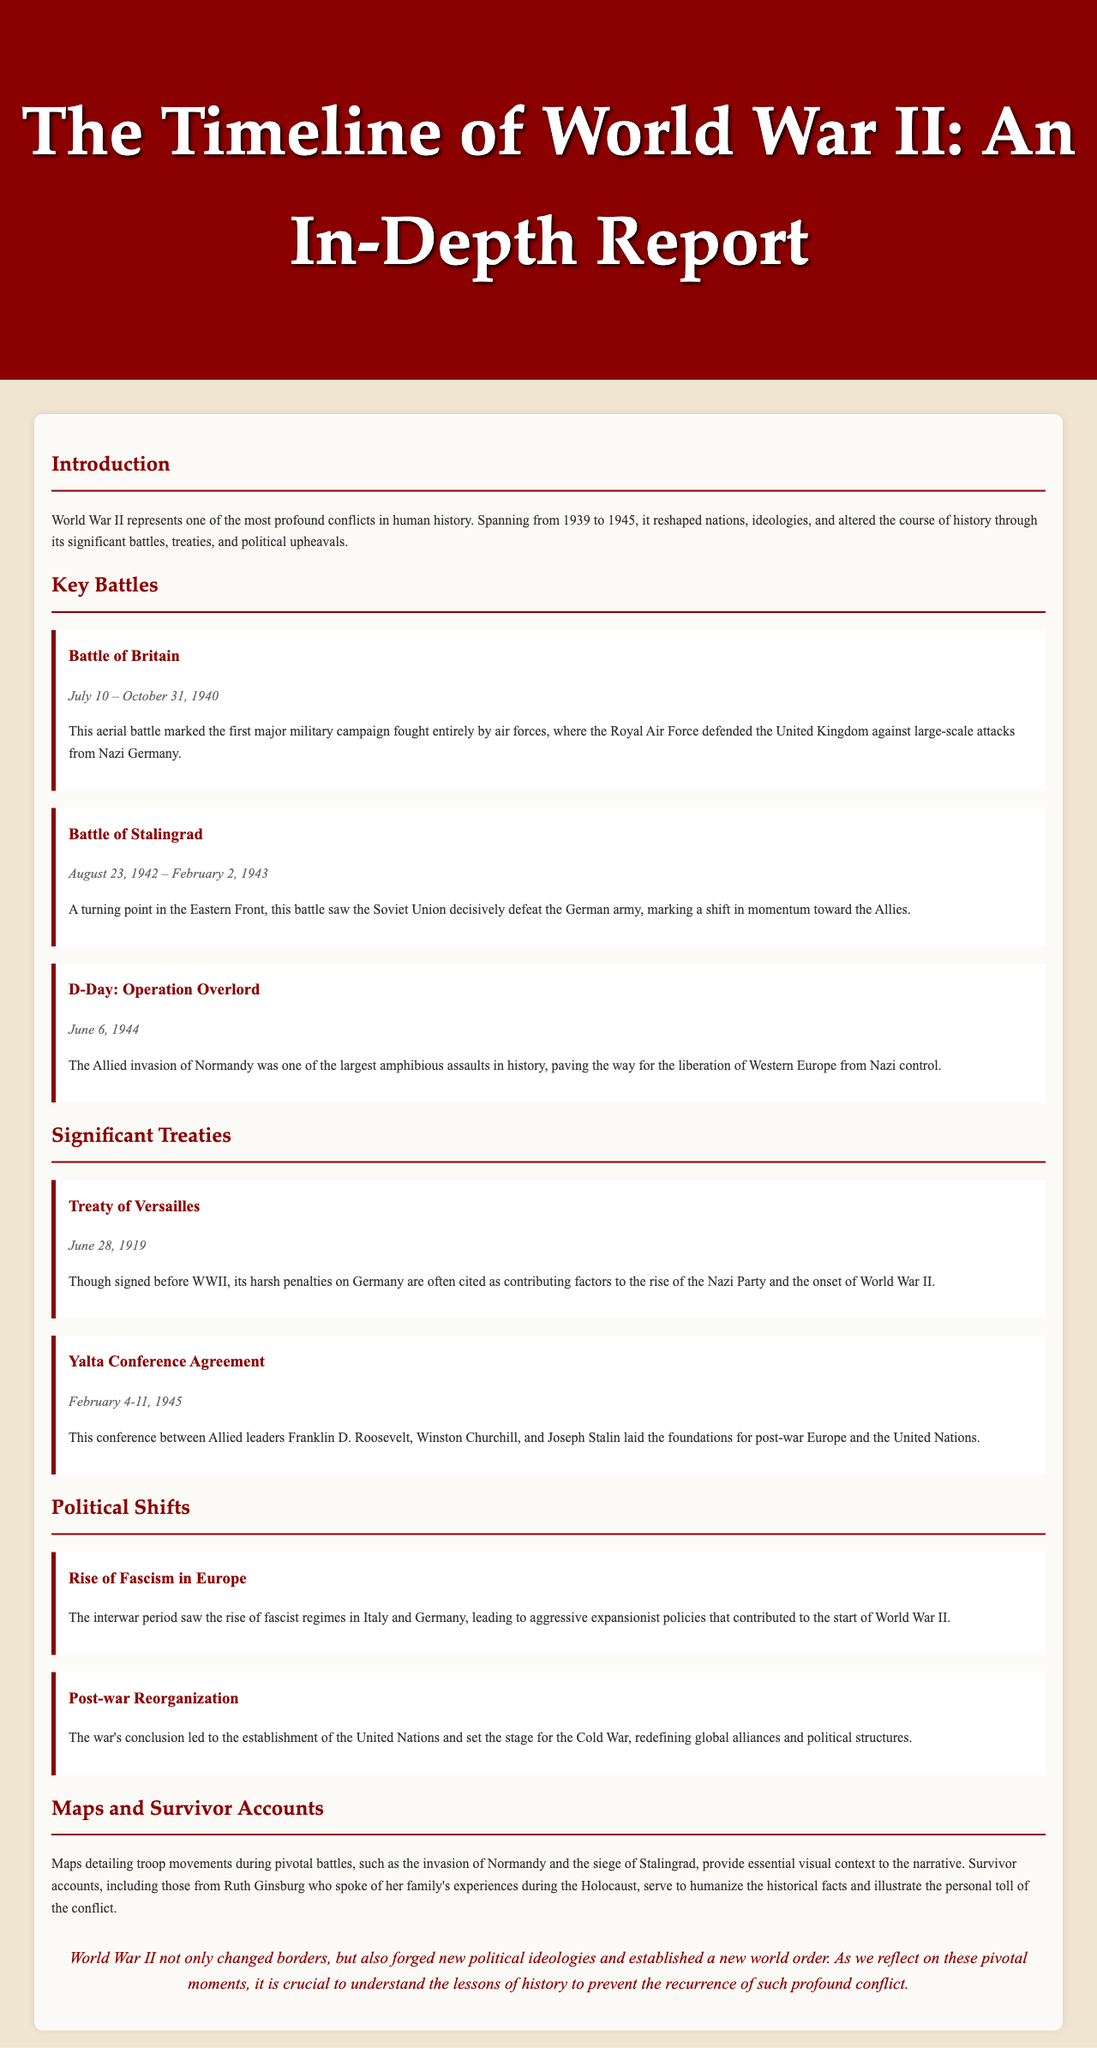What were the dates of the Battle of Britain? The document states the Battle of Britain took place from July 10 to October 31, 1940.
Answer: July 10 – October 31, 1940 What was a turning point on the Eastern Front? The Battle of Stalingrad is highlighted as a decisive battle where the Soviet Union defeated the German army, marking a shift in momentum.
Answer: Battle of Stalingrad When did D-Day occur? The document indicates that D-Day, or Operation Overlord, occurred on June 6, 1944.
Answer: June 6, 1944 What significant treaty was signed on June 28, 1919? The Treaty of Versailles, signed before WWII, is cited for its role in influencing the onset of World War II.
Answer: Treaty of Versailles What was established after the war's conclusion? The document notes the establishment of the United Nations as one of the significant outcomes following the end of World War II.
Answer: United Nations Which leaders attended the Yalta Conference? The document mentions Franklin D. Roosevelt, Winston Churchill, and Joseph Stalin as the key participants of the Yalta Conference.
Answer: Franklin D. Roosevelt, Winston Churchill, Joseph Stalin What ideology rose in Europe during the interwar period? The document discusses the rise of fascism as a critical issue contributing to the events leading up to World War II.
Answer: Fascism Which battle's maps provide visual context to the report? The report mentions maps detailing troop movements during the invasion of Normandy and the siege of Stalingrad, providing essential visual context.
Answer: Invasion of Normandy and siege of Stalingrad Who provided survivor accounts in the report? The document specifically mentions Ruth Ginsburg as one of the individuals who spoke about her family's experiences during the Holocaust.
Answer: Ruth Ginsburg 